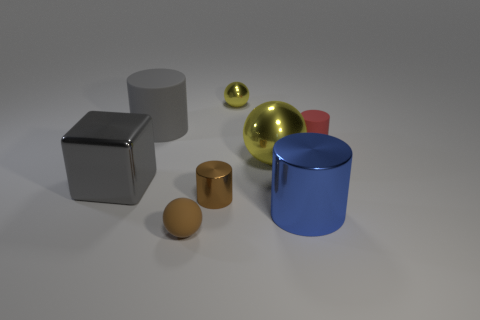Subtract all rubber spheres. How many spheres are left? 2 Subtract all blue blocks. How many yellow balls are left? 2 Subtract all red cylinders. How many cylinders are left? 3 Add 1 spheres. How many objects exist? 9 Subtract 1 spheres. How many spheres are left? 2 Subtract all cubes. How many objects are left? 7 Subtract all cyan balls. Subtract all blue cylinders. How many balls are left? 3 Add 3 big rubber blocks. How many big rubber blocks exist? 3 Subtract 1 brown spheres. How many objects are left? 7 Subtract all big yellow metallic things. Subtract all gray cylinders. How many objects are left? 6 